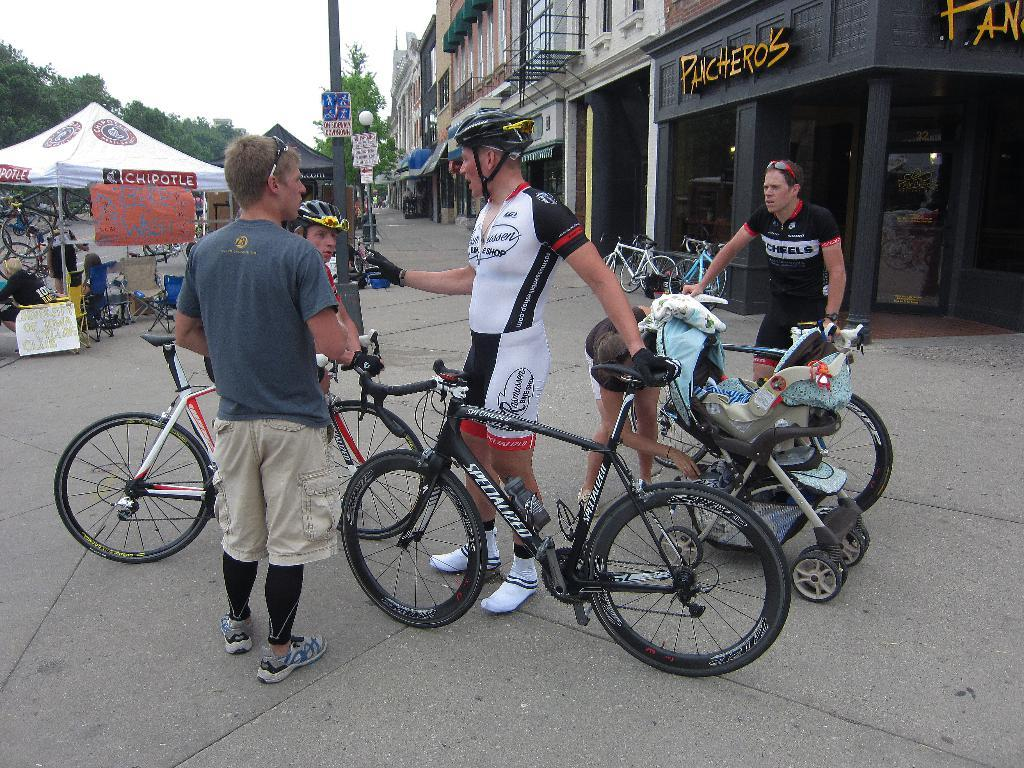Who or what can be seen in the image? There are people in the image. What objects are on the ground in the image? There are bicycles on the ground. What structures can be seen in the background of the image? There are buildings, tents, trees, and poles in the background. What part of the natural environment is visible in the image? The sky is visible in the background. Can you describe any unspecified objects in the background? There are some unspecified objects in the background, but their details are not clear from the image. What type of chalk is being used for arithmetic in the image? There is no chalk or arithmetic activity present in the image. What rhythm is being played by the people in the image? There is no indication of any musical activity or rhythm in the image. 